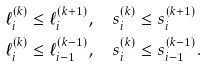<formula> <loc_0><loc_0><loc_500><loc_500>\ell _ { i } ^ { ( k ) } & \leq \ell _ { i } ^ { ( k + 1 ) } , \quad s _ { i } ^ { ( k ) } \leq s _ { i } ^ { ( k + 1 ) } \\ \ell _ { i } ^ { ( k ) } & \leq \ell _ { i - 1 } ^ { ( k - 1 ) } , \quad s _ { i } ^ { ( k ) } \leq s _ { i - 1 } ^ { ( k - 1 ) } .</formula> 